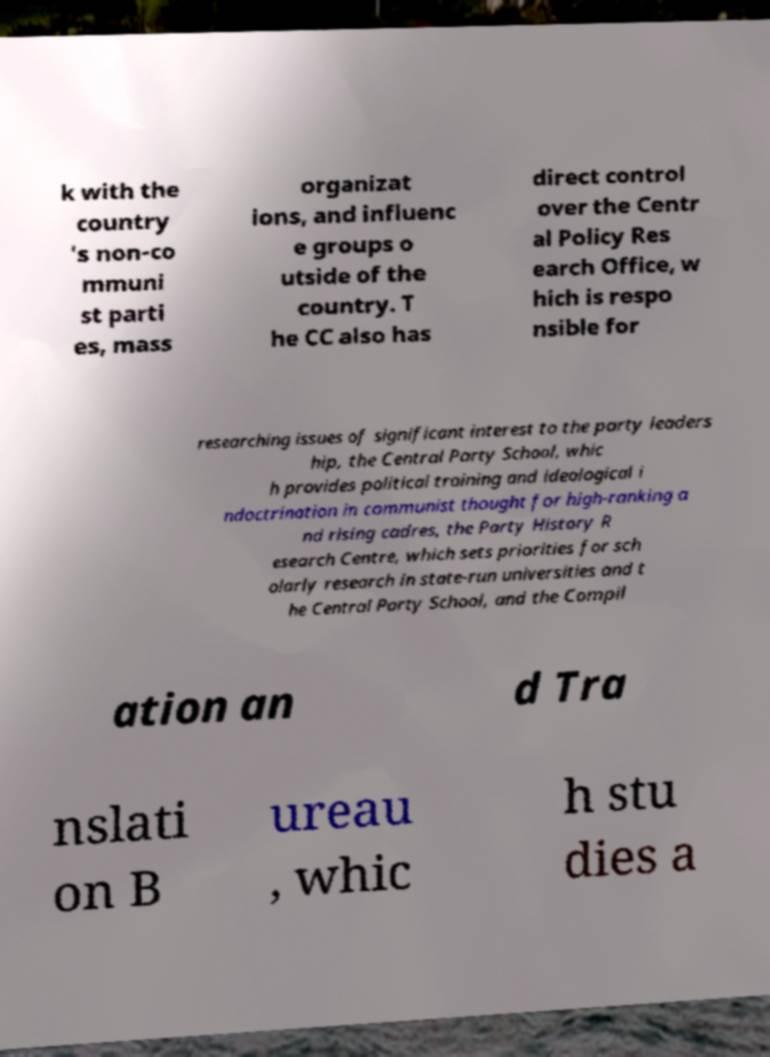Can you read and provide the text displayed in the image?This photo seems to have some interesting text. Can you extract and type it out for me? k with the country 's non-co mmuni st parti es, mass organizat ions, and influenc e groups o utside of the country. T he CC also has direct control over the Centr al Policy Res earch Office, w hich is respo nsible for researching issues of significant interest to the party leaders hip, the Central Party School, whic h provides political training and ideological i ndoctrination in communist thought for high-ranking a nd rising cadres, the Party History R esearch Centre, which sets priorities for sch olarly research in state-run universities and t he Central Party School, and the Compil ation an d Tra nslati on B ureau , whic h stu dies a 